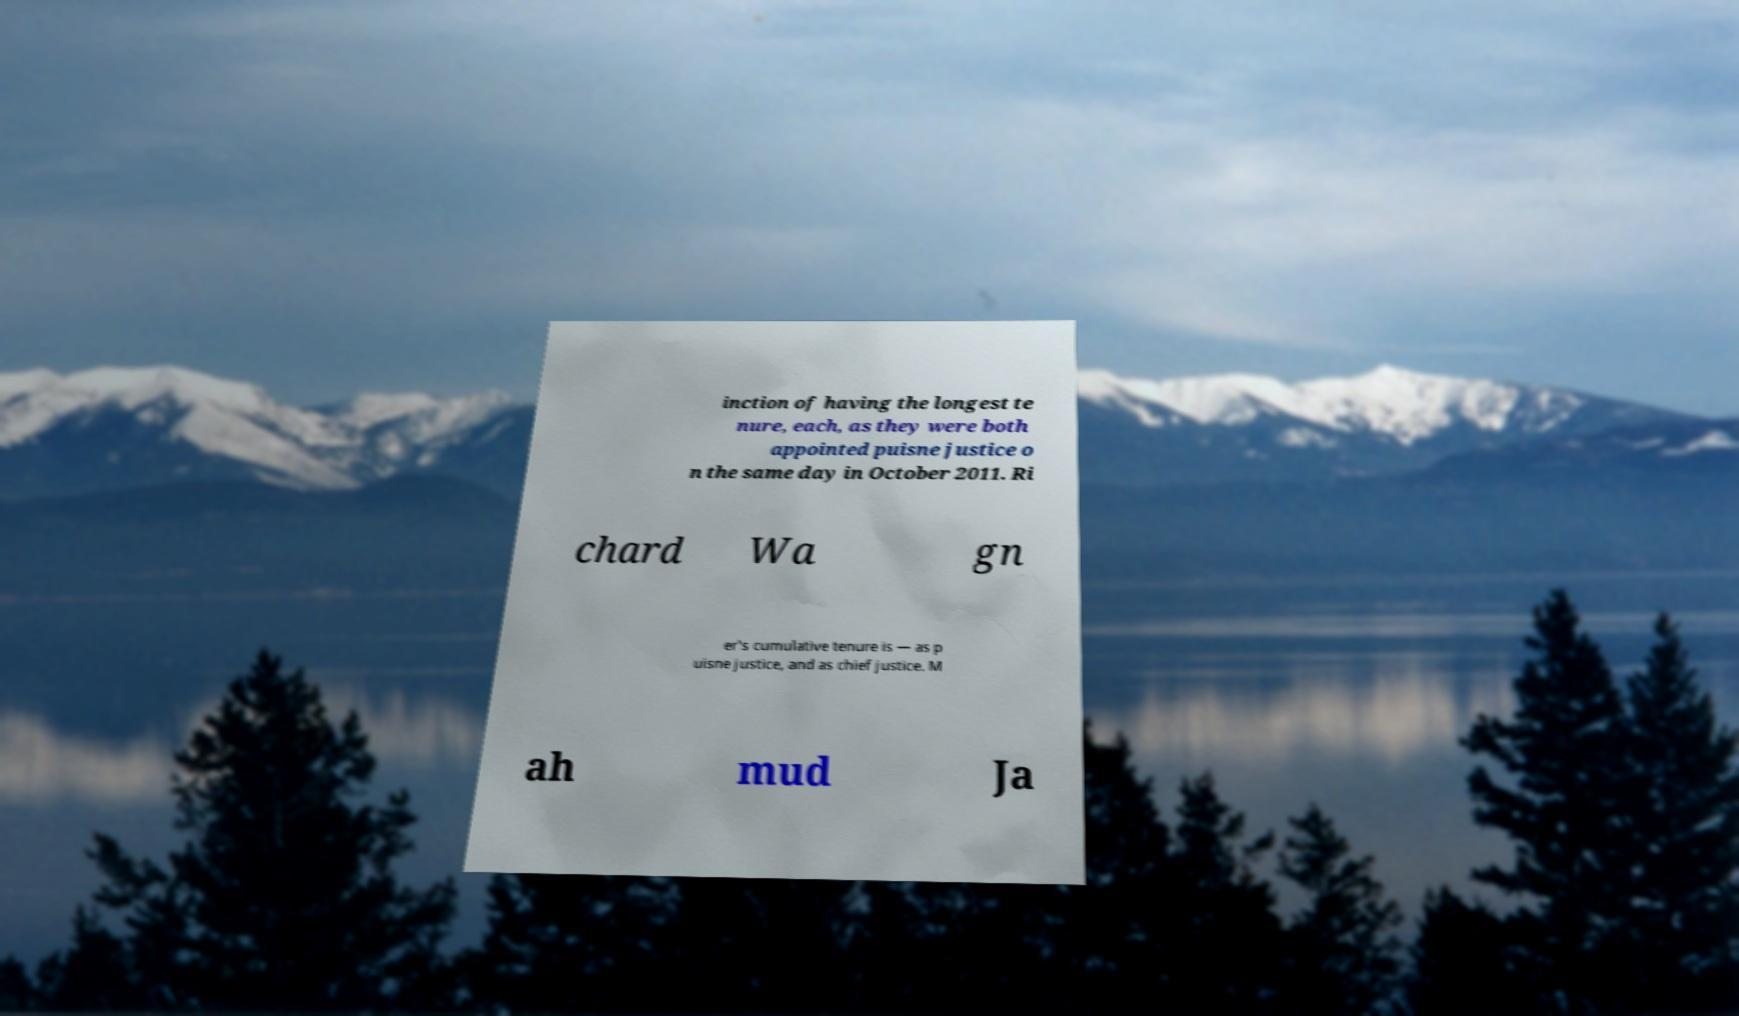Could you extract and type out the text from this image? inction of having the longest te nure, each, as they were both appointed puisne justice o n the same day in October 2011. Ri chard Wa gn er's cumulative tenure is — as p uisne justice, and as chief justice. M ah mud Ja 